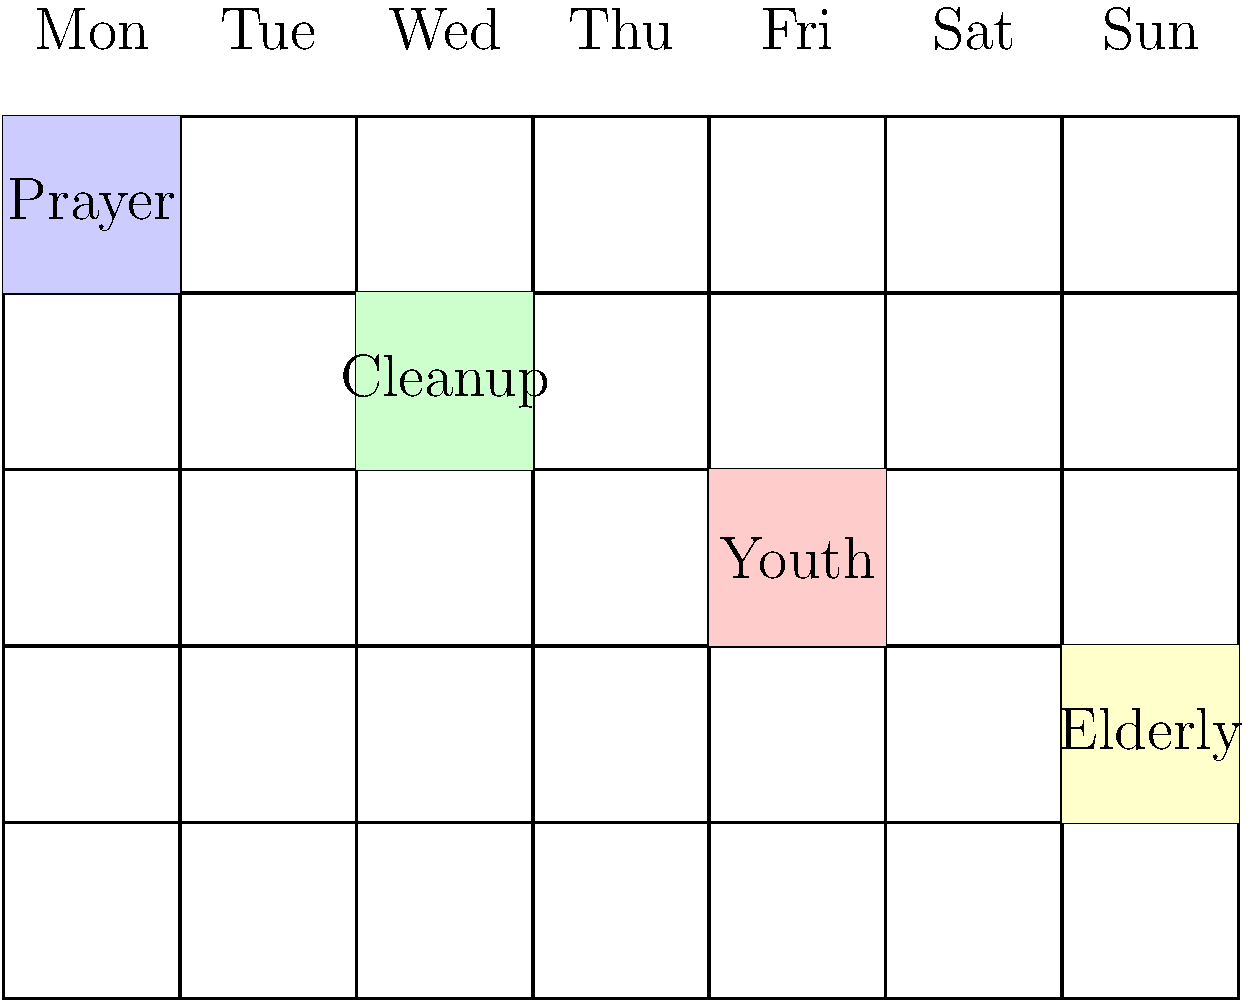Based on the weekly volunteer schedule shown in the grid, which day has the Youth activity scheduled, and how many days after the Prayer activity does it occur? To solve this question, let's follow these steps:

1. Identify the day for the Prayer activity:
   - The Prayer activity is scheduled on Monday (first column).

2. Identify the day for the Youth activity:
   - The Youth activity is scheduled on Friday (fifth column).

3. Count the number of days between Prayer and Youth activities:
   - Monday to Tuesday: 1 day
   - Tuesday to Wednesday: 2 days
   - Wednesday to Thursday: 3 days
   - Thursday to Friday: 4 days

Therefore, the Youth activity is scheduled on Friday, which is 4 days after the Prayer activity on Monday.
Answer: Friday, 4 days 